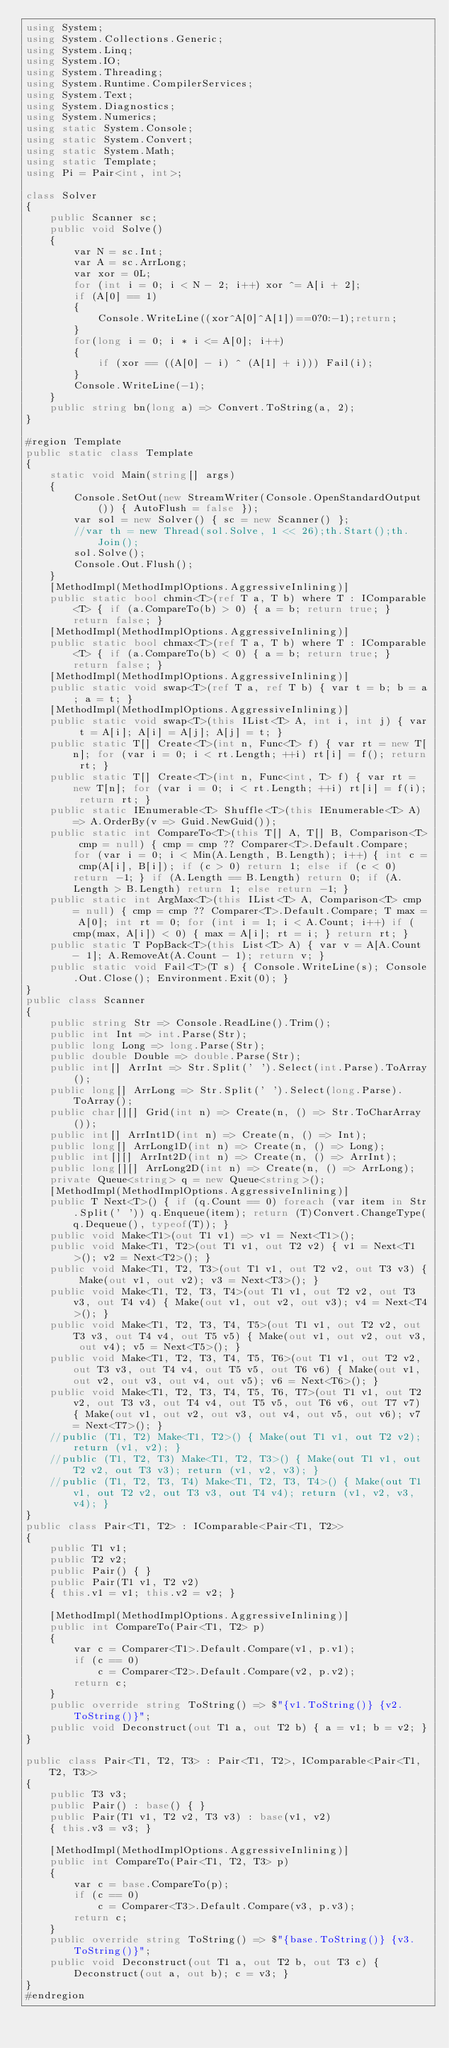Convert code to text. <code><loc_0><loc_0><loc_500><loc_500><_C#_>using System;
using System.Collections.Generic;
using System.Linq;
using System.IO;
using System.Threading;
using System.Runtime.CompilerServices;
using System.Text;
using System.Diagnostics;
using System.Numerics;
using static System.Console;
using static System.Convert;
using static System.Math;
using static Template;
using Pi = Pair<int, int>;

class Solver
{
    public Scanner sc;
    public void Solve()
    {
        var N = sc.Int;
        var A = sc.ArrLong;
        var xor = 0L;
        for (int i = 0; i < N - 2; i++) xor ^= A[i + 2];
        if (A[0] == 1)
        {
            Console.WriteLine((xor^A[0]^A[1])==0?0:-1);return;
        }
        for(long i = 0; i * i <= A[0]; i++)
        {
            if (xor == ((A[0] - i) ^ (A[1] + i))) Fail(i);
        }
        Console.WriteLine(-1);
    }
    public string bn(long a) => Convert.ToString(a, 2);
}

#region Template
public static class Template
{
    static void Main(string[] args)
    {
        Console.SetOut(new StreamWriter(Console.OpenStandardOutput()) { AutoFlush = false });
        var sol = new Solver() { sc = new Scanner() };
        //var th = new Thread(sol.Solve, 1 << 26);th.Start();th.Join();
        sol.Solve();
        Console.Out.Flush();
    }
    [MethodImpl(MethodImplOptions.AggressiveInlining)]
    public static bool chmin<T>(ref T a, T b) where T : IComparable<T> { if (a.CompareTo(b) > 0) { a = b; return true; } return false; }
    [MethodImpl(MethodImplOptions.AggressiveInlining)]
    public static bool chmax<T>(ref T a, T b) where T : IComparable<T> { if (a.CompareTo(b) < 0) { a = b; return true; } return false; }
    [MethodImpl(MethodImplOptions.AggressiveInlining)]
    public static void swap<T>(ref T a, ref T b) { var t = b; b = a; a = t; }
    [MethodImpl(MethodImplOptions.AggressiveInlining)]
    public static void swap<T>(this IList<T> A, int i, int j) { var t = A[i]; A[i] = A[j]; A[j] = t; }
    public static T[] Create<T>(int n, Func<T> f) { var rt = new T[n]; for (var i = 0; i < rt.Length; ++i) rt[i] = f(); return rt; }
    public static T[] Create<T>(int n, Func<int, T> f) { var rt = new T[n]; for (var i = 0; i < rt.Length; ++i) rt[i] = f(i); return rt; }
    public static IEnumerable<T> Shuffle<T>(this IEnumerable<T> A) => A.OrderBy(v => Guid.NewGuid());
    public static int CompareTo<T>(this T[] A, T[] B, Comparison<T> cmp = null) { cmp = cmp ?? Comparer<T>.Default.Compare; for (var i = 0; i < Min(A.Length, B.Length); i++) { int c = cmp(A[i], B[i]); if (c > 0) return 1; else if (c < 0) return -1; } if (A.Length == B.Length) return 0; if (A.Length > B.Length) return 1; else return -1; }
    public static int ArgMax<T>(this IList<T> A, Comparison<T> cmp = null) { cmp = cmp ?? Comparer<T>.Default.Compare; T max = A[0]; int rt = 0; for (int i = 1; i < A.Count; i++) if (cmp(max, A[i]) < 0) { max = A[i]; rt = i; } return rt; }
    public static T PopBack<T>(this List<T> A) { var v = A[A.Count - 1]; A.RemoveAt(A.Count - 1); return v; }
    public static void Fail<T>(T s) { Console.WriteLine(s); Console.Out.Close(); Environment.Exit(0); }
}
public class Scanner
{
    public string Str => Console.ReadLine().Trim();
    public int Int => int.Parse(Str);
    public long Long => long.Parse(Str);
    public double Double => double.Parse(Str);
    public int[] ArrInt => Str.Split(' ').Select(int.Parse).ToArray();
    public long[] ArrLong => Str.Split(' ').Select(long.Parse).ToArray();
    public char[][] Grid(int n) => Create(n, () => Str.ToCharArray());
    public int[] ArrInt1D(int n) => Create(n, () => Int);
    public long[] ArrLong1D(int n) => Create(n, () => Long);
    public int[][] ArrInt2D(int n) => Create(n, () => ArrInt);
    public long[][] ArrLong2D(int n) => Create(n, () => ArrLong);
    private Queue<string> q = new Queue<string>();
    [MethodImpl(MethodImplOptions.AggressiveInlining)]
    public T Next<T>() { if (q.Count == 0) foreach (var item in Str.Split(' ')) q.Enqueue(item); return (T)Convert.ChangeType(q.Dequeue(), typeof(T)); }
    public void Make<T1>(out T1 v1) => v1 = Next<T1>();
    public void Make<T1, T2>(out T1 v1, out T2 v2) { v1 = Next<T1>(); v2 = Next<T2>(); }
    public void Make<T1, T2, T3>(out T1 v1, out T2 v2, out T3 v3) { Make(out v1, out v2); v3 = Next<T3>(); }
    public void Make<T1, T2, T3, T4>(out T1 v1, out T2 v2, out T3 v3, out T4 v4) { Make(out v1, out v2, out v3); v4 = Next<T4>(); }
    public void Make<T1, T2, T3, T4, T5>(out T1 v1, out T2 v2, out T3 v3, out T4 v4, out T5 v5) { Make(out v1, out v2, out v3, out v4); v5 = Next<T5>(); }
    public void Make<T1, T2, T3, T4, T5, T6>(out T1 v1, out T2 v2, out T3 v3, out T4 v4, out T5 v5, out T6 v6) { Make(out v1, out v2, out v3, out v4, out v5); v6 = Next<T6>(); }
    public void Make<T1, T2, T3, T4, T5, T6, T7>(out T1 v1, out T2 v2, out T3 v3, out T4 v4, out T5 v5, out T6 v6, out T7 v7) { Make(out v1, out v2, out v3, out v4, out v5, out v6); v7 = Next<T7>(); }
    //public (T1, T2) Make<T1, T2>() { Make(out T1 v1, out T2 v2); return (v1, v2); }
    //public (T1, T2, T3) Make<T1, T2, T3>() { Make(out T1 v1, out T2 v2, out T3 v3); return (v1, v2, v3); }
    //public (T1, T2, T3, T4) Make<T1, T2, T3, T4>() { Make(out T1 v1, out T2 v2, out T3 v3, out T4 v4); return (v1, v2, v3, v4); }
}
public class Pair<T1, T2> : IComparable<Pair<T1, T2>>
{
    public T1 v1;
    public T2 v2;
    public Pair() { }
    public Pair(T1 v1, T2 v2)
    { this.v1 = v1; this.v2 = v2; }

    [MethodImpl(MethodImplOptions.AggressiveInlining)]
    public int CompareTo(Pair<T1, T2> p)
    {
        var c = Comparer<T1>.Default.Compare(v1, p.v1);
        if (c == 0)
            c = Comparer<T2>.Default.Compare(v2, p.v2);
        return c;
    }
    public override string ToString() => $"{v1.ToString()} {v2.ToString()}";
    public void Deconstruct(out T1 a, out T2 b) { a = v1; b = v2; }
}

public class Pair<T1, T2, T3> : Pair<T1, T2>, IComparable<Pair<T1, T2, T3>>
{
    public T3 v3;
    public Pair() : base() { }
    public Pair(T1 v1, T2 v2, T3 v3) : base(v1, v2)
    { this.v3 = v3; }

    [MethodImpl(MethodImplOptions.AggressiveInlining)]
    public int CompareTo(Pair<T1, T2, T3> p)
    {
        var c = base.CompareTo(p);
        if (c == 0)
            c = Comparer<T3>.Default.Compare(v3, p.v3);
        return c;
    }
    public override string ToString() => $"{base.ToString()} {v3.ToString()}";
    public void Deconstruct(out T1 a, out T2 b, out T3 c) { Deconstruct(out a, out b); c = v3; }
}
#endregion</code> 